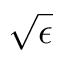<formula> <loc_0><loc_0><loc_500><loc_500>\sqrt { \epsilon }</formula> 